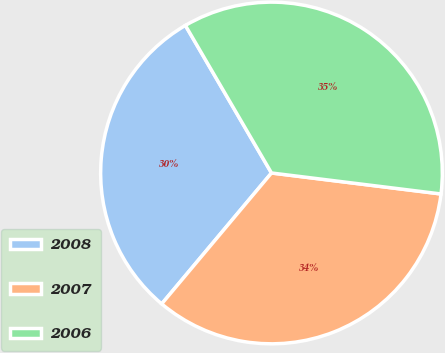<chart> <loc_0><loc_0><loc_500><loc_500><pie_chart><fcel>2008<fcel>2007<fcel>2006<nl><fcel>30.49%<fcel>34.15%<fcel>35.37%<nl></chart> 